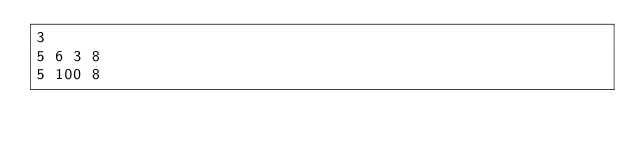<code> <loc_0><loc_0><loc_500><loc_500><_C++_>3
5 6 3 8
5 100 8</code> 